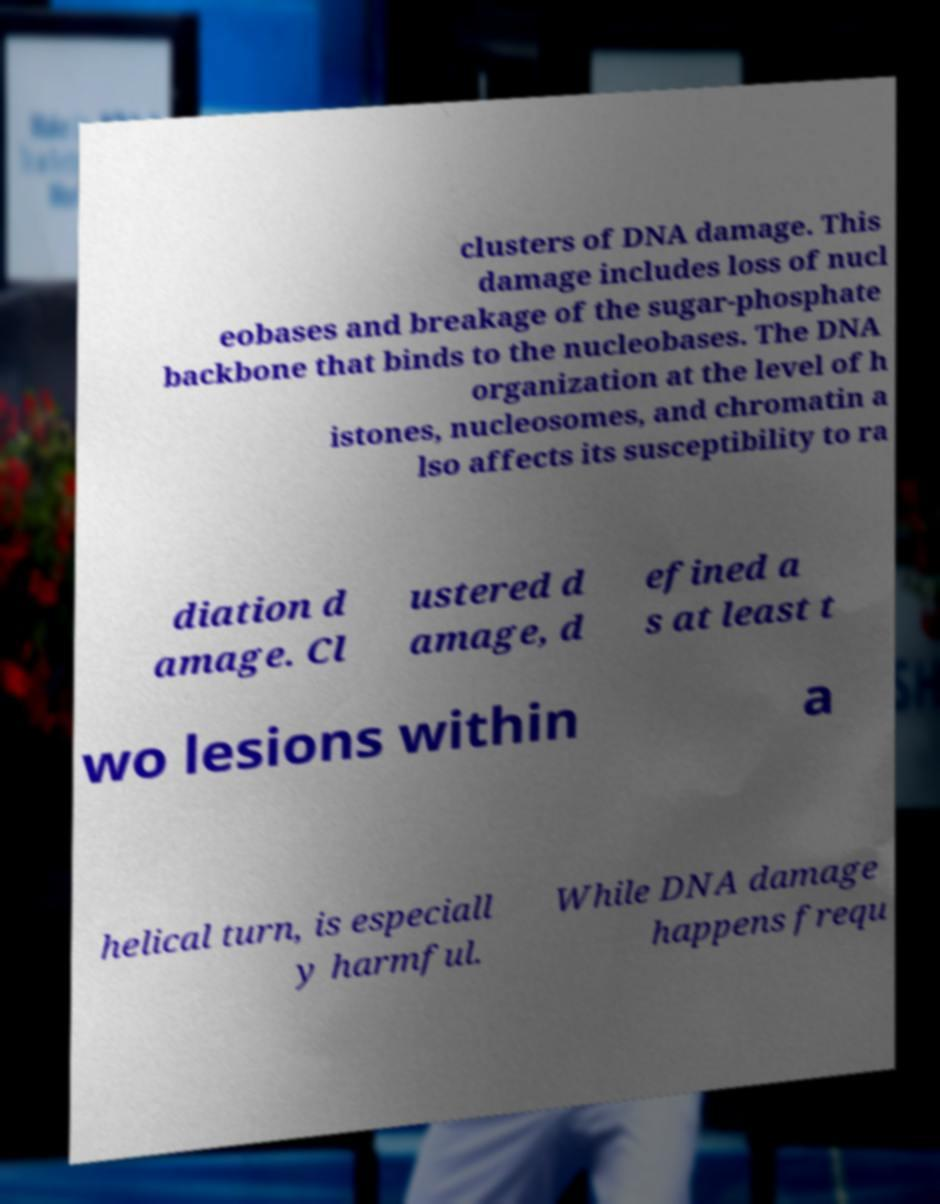Please identify and transcribe the text found in this image. clusters of DNA damage. This damage includes loss of nucl eobases and breakage of the sugar-phosphate backbone that binds to the nucleobases. The DNA organization at the level of h istones, nucleosomes, and chromatin a lso affects its susceptibility to ra diation d amage. Cl ustered d amage, d efined a s at least t wo lesions within a helical turn, is especiall y harmful. While DNA damage happens frequ 